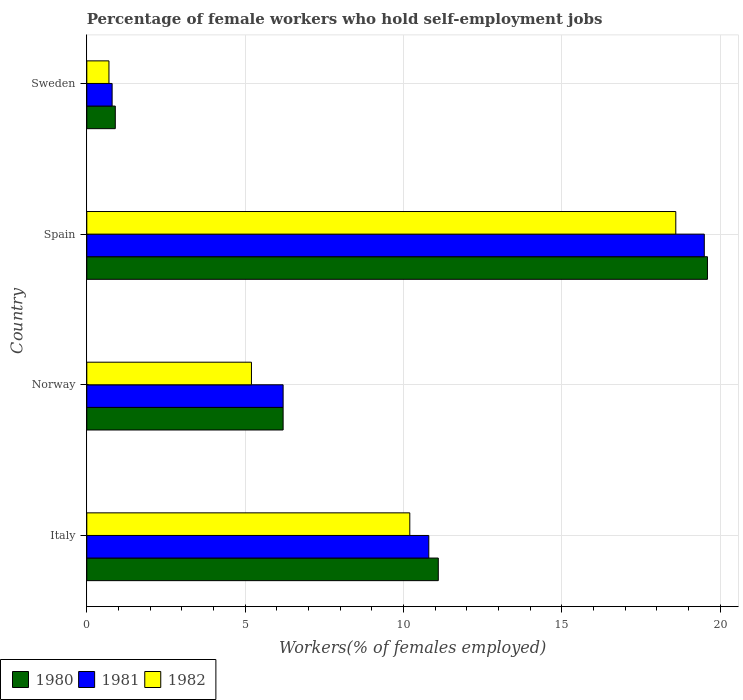Are the number of bars on each tick of the Y-axis equal?
Your answer should be compact. Yes. How many bars are there on the 3rd tick from the bottom?
Your answer should be compact. 3. In how many cases, is the number of bars for a given country not equal to the number of legend labels?
Give a very brief answer. 0. What is the percentage of self-employed female workers in 1980 in Norway?
Provide a short and direct response. 6.2. Across all countries, what is the maximum percentage of self-employed female workers in 1982?
Offer a terse response. 18.6. Across all countries, what is the minimum percentage of self-employed female workers in 1980?
Provide a short and direct response. 0.9. In which country was the percentage of self-employed female workers in 1981 maximum?
Provide a succinct answer. Spain. What is the total percentage of self-employed female workers in 1981 in the graph?
Provide a short and direct response. 37.3. What is the difference between the percentage of self-employed female workers in 1982 in Italy and that in Spain?
Keep it short and to the point. -8.4. What is the difference between the percentage of self-employed female workers in 1982 in Norway and the percentage of self-employed female workers in 1980 in Sweden?
Ensure brevity in your answer.  4.3. What is the average percentage of self-employed female workers in 1981 per country?
Offer a very short reply. 9.33. What is the difference between the percentage of self-employed female workers in 1982 and percentage of self-employed female workers in 1980 in Norway?
Ensure brevity in your answer.  -1. What is the ratio of the percentage of self-employed female workers in 1980 in Italy to that in Spain?
Offer a very short reply. 0.57. Is the difference between the percentage of self-employed female workers in 1982 in Italy and Norway greater than the difference between the percentage of self-employed female workers in 1980 in Italy and Norway?
Make the answer very short. Yes. What is the difference between the highest and the second highest percentage of self-employed female workers in 1981?
Provide a short and direct response. 8.7. What is the difference between the highest and the lowest percentage of self-employed female workers in 1981?
Your answer should be compact. 18.7. Is the sum of the percentage of self-employed female workers in 1981 in Norway and Sweden greater than the maximum percentage of self-employed female workers in 1980 across all countries?
Give a very brief answer. No. What does the 1st bar from the top in Sweden represents?
Give a very brief answer. 1982. What does the 2nd bar from the bottom in Sweden represents?
Your answer should be very brief. 1981. Are all the bars in the graph horizontal?
Provide a succinct answer. Yes. How many countries are there in the graph?
Offer a terse response. 4. Does the graph contain grids?
Ensure brevity in your answer.  Yes. How many legend labels are there?
Provide a succinct answer. 3. How are the legend labels stacked?
Offer a very short reply. Horizontal. What is the title of the graph?
Provide a succinct answer. Percentage of female workers who hold self-employment jobs. Does "2012" appear as one of the legend labels in the graph?
Offer a very short reply. No. What is the label or title of the X-axis?
Offer a very short reply. Workers(% of females employed). What is the label or title of the Y-axis?
Your answer should be very brief. Country. What is the Workers(% of females employed) of 1980 in Italy?
Your response must be concise. 11.1. What is the Workers(% of females employed) in 1981 in Italy?
Your answer should be very brief. 10.8. What is the Workers(% of females employed) of 1982 in Italy?
Your answer should be very brief. 10.2. What is the Workers(% of females employed) of 1980 in Norway?
Offer a terse response. 6.2. What is the Workers(% of females employed) in 1981 in Norway?
Offer a very short reply. 6.2. What is the Workers(% of females employed) of 1982 in Norway?
Ensure brevity in your answer.  5.2. What is the Workers(% of females employed) in 1980 in Spain?
Keep it short and to the point. 19.6. What is the Workers(% of females employed) in 1982 in Spain?
Offer a very short reply. 18.6. What is the Workers(% of females employed) in 1980 in Sweden?
Provide a short and direct response. 0.9. What is the Workers(% of females employed) of 1981 in Sweden?
Your answer should be compact. 0.8. What is the Workers(% of females employed) of 1982 in Sweden?
Provide a succinct answer. 0.7. Across all countries, what is the maximum Workers(% of females employed) in 1980?
Offer a terse response. 19.6. Across all countries, what is the maximum Workers(% of females employed) in 1981?
Your answer should be very brief. 19.5. Across all countries, what is the maximum Workers(% of females employed) of 1982?
Keep it short and to the point. 18.6. Across all countries, what is the minimum Workers(% of females employed) in 1980?
Ensure brevity in your answer.  0.9. Across all countries, what is the minimum Workers(% of females employed) in 1981?
Offer a very short reply. 0.8. Across all countries, what is the minimum Workers(% of females employed) in 1982?
Provide a succinct answer. 0.7. What is the total Workers(% of females employed) in 1980 in the graph?
Give a very brief answer. 37.8. What is the total Workers(% of females employed) of 1981 in the graph?
Your answer should be compact. 37.3. What is the total Workers(% of females employed) in 1982 in the graph?
Provide a succinct answer. 34.7. What is the difference between the Workers(% of females employed) of 1981 in Italy and that in Norway?
Ensure brevity in your answer.  4.6. What is the difference between the Workers(% of females employed) in 1980 in Italy and that in Spain?
Keep it short and to the point. -8.5. What is the difference between the Workers(% of females employed) in 1981 in Italy and that in Spain?
Provide a short and direct response. -8.7. What is the difference between the Workers(% of females employed) in 1982 in Italy and that in Sweden?
Offer a terse response. 9.5. What is the difference between the Workers(% of females employed) in 1980 in Norway and that in Spain?
Your response must be concise. -13.4. What is the difference between the Workers(% of females employed) of 1981 in Norway and that in Spain?
Keep it short and to the point. -13.3. What is the difference between the Workers(% of females employed) in 1982 in Norway and that in Spain?
Your answer should be very brief. -13.4. What is the difference between the Workers(% of females employed) in 1981 in Norway and that in Sweden?
Your answer should be very brief. 5.4. What is the difference between the Workers(% of females employed) of 1982 in Norway and that in Sweden?
Give a very brief answer. 4.5. What is the difference between the Workers(% of females employed) in 1981 in Spain and that in Sweden?
Keep it short and to the point. 18.7. What is the difference between the Workers(% of females employed) in 1980 in Italy and the Workers(% of females employed) in 1981 in Norway?
Your answer should be compact. 4.9. What is the difference between the Workers(% of females employed) in 1981 in Italy and the Workers(% of females employed) in 1982 in Norway?
Ensure brevity in your answer.  5.6. What is the difference between the Workers(% of females employed) in 1981 in Italy and the Workers(% of females employed) in 1982 in Spain?
Ensure brevity in your answer.  -7.8. What is the difference between the Workers(% of females employed) in 1981 in Norway and the Workers(% of females employed) in 1982 in Spain?
Your answer should be very brief. -12.4. What is the difference between the Workers(% of females employed) in 1980 in Norway and the Workers(% of females employed) in 1981 in Sweden?
Provide a succinct answer. 5.4. What is the average Workers(% of females employed) in 1980 per country?
Keep it short and to the point. 9.45. What is the average Workers(% of females employed) of 1981 per country?
Your answer should be compact. 9.32. What is the average Workers(% of females employed) in 1982 per country?
Give a very brief answer. 8.68. What is the difference between the Workers(% of females employed) of 1981 and Workers(% of females employed) of 1982 in Italy?
Provide a short and direct response. 0.6. What is the difference between the Workers(% of females employed) in 1980 and Workers(% of females employed) in 1982 in Norway?
Ensure brevity in your answer.  1. What is the difference between the Workers(% of females employed) of 1981 and Workers(% of females employed) of 1982 in Norway?
Your answer should be very brief. 1. What is the difference between the Workers(% of females employed) in 1980 and Workers(% of females employed) in 1981 in Spain?
Keep it short and to the point. 0.1. What is the difference between the Workers(% of females employed) of 1980 and Workers(% of females employed) of 1982 in Spain?
Ensure brevity in your answer.  1. What is the difference between the Workers(% of females employed) of 1980 and Workers(% of females employed) of 1981 in Sweden?
Your answer should be very brief. 0.1. What is the difference between the Workers(% of females employed) of 1980 and Workers(% of females employed) of 1982 in Sweden?
Make the answer very short. 0.2. What is the ratio of the Workers(% of females employed) in 1980 in Italy to that in Norway?
Ensure brevity in your answer.  1.79. What is the ratio of the Workers(% of females employed) of 1981 in Italy to that in Norway?
Offer a terse response. 1.74. What is the ratio of the Workers(% of females employed) of 1982 in Italy to that in Norway?
Your response must be concise. 1.96. What is the ratio of the Workers(% of females employed) in 1980 in Italy to that in Spain?
Keep it short and to the point. 0.57. What is the ratio of the Workers(% of females employed) in 1981 in Italy to that in Spain?
Offer a very short reply. 0.55. What is the ratio of the Workers(% of females employed) of 1982 in Italy to that in Spain?
Ensure brevity in your answer.  0.55. What is the ratio of the Workers(% of females employed) in 1980 in Italy to that in Sweden?
Give a very brief answer. 12.33. What is the ratio of the Workers(% of females employed) of 1981 in Italy to that in Sweden?
Your response must be concise. 13.5. What is the ratio of the Workers(% of females employed) in 1982 in Italy to that in Sweden?
Make the answer very short. 14.57. What is the ratio of the Workers(% of females employed) of 1980 in Norway to that in Spain?
Give a very brief answer. 0.32. What is the ratio of the Workers(% of females employed) in 1981 in Norway to that in Spain?
Keep it short and to the point. 0.32. What is the ratio of the Workers(% of females employed) of 1982 in Norway to that in Spain?
Make the answer very short. 0.28. What is the ratio of the Workers(% of females employed) in 1980 in Norway to that in Sweden?
Provide a succinct answer. 6.89. What is the ratio of the Workers(% of females employed) in 1981 in Norway to that in Sweden?
Offer a very short reply. 7.75. What is the ratio of the Workers(% of females employed) in 1982 in Norway to that in Sweden?
Offer a terse response. 7.43. What is the ratio of the Workers(% of females employed) in 1980 in Spain to that in Sweden?
Give a very brief answer. 21.78. What is the ratio of the Workers(% of females employed) in 1981 in Spain to that in Sweden?
Give a very brief answer. 24.38. What is the ratio of the Workers(% of females employed) of 1982 in Spain to that in Sweden?
Your response must be concise. 26.57. What is the difference between the highest and the second highest Workers(% of females employed) of 1981?
Make the answer very short. 8.7. What is the difference between the highest and the lowest Workers(% of females employed) of 1980?
Your answer should be very brief. 18.7. 